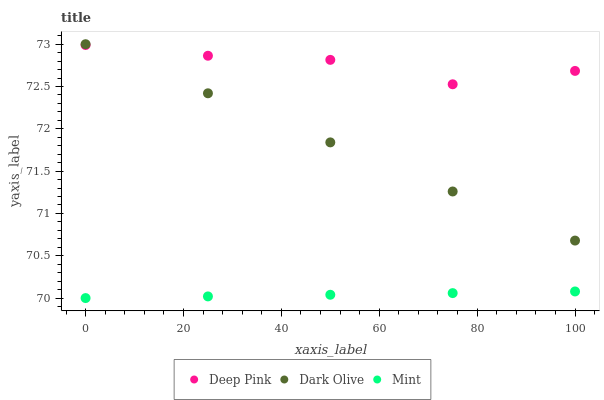Does Mint have the minimum area under the curve?
Answer yes or no. Yes. Does Deep Pink have the maximum area under the curve?
Answer yes or no. Yes. Does Deep Pink have the minimum area under the curve?
Answer yes or no. No. Does Mint have the maximum area under the curve?
Answer yes or no. No. Is Dark Olive the smoothest?
Answer yes or no. Yes. Is Deep Pink the roughest?
Answer yes or no. Yes. Is Mint the smoothest?
Answer yes or no. No. Is Mint the roughest?
Answer yes or no. No. Does Mint have the lowest value?
Answer yes or no. Yes. Does Deep Pink have the lowest value?
Answer yes or no. No. Does Dark Olive have the highest value?
Answer yes or no. Yes. Does Deep Pink have the highest value?
Answer yes or no. No. Is Mint less than Dark Olive?
Answer yes or no. Yes. Is Dark Olive greater than Mint?
Answer yes or no. Yes. Does Dark Olive intersect Deep Pink?
Answer yes or no. Yes. Is Dark Olive less than Deep Pink?
Answer yes or no. No. Is Dark Olive greater than Deep Pink?
Answer yes or no. No. Does Mint intersect Dark Olive?
Answer yes or no. No. 